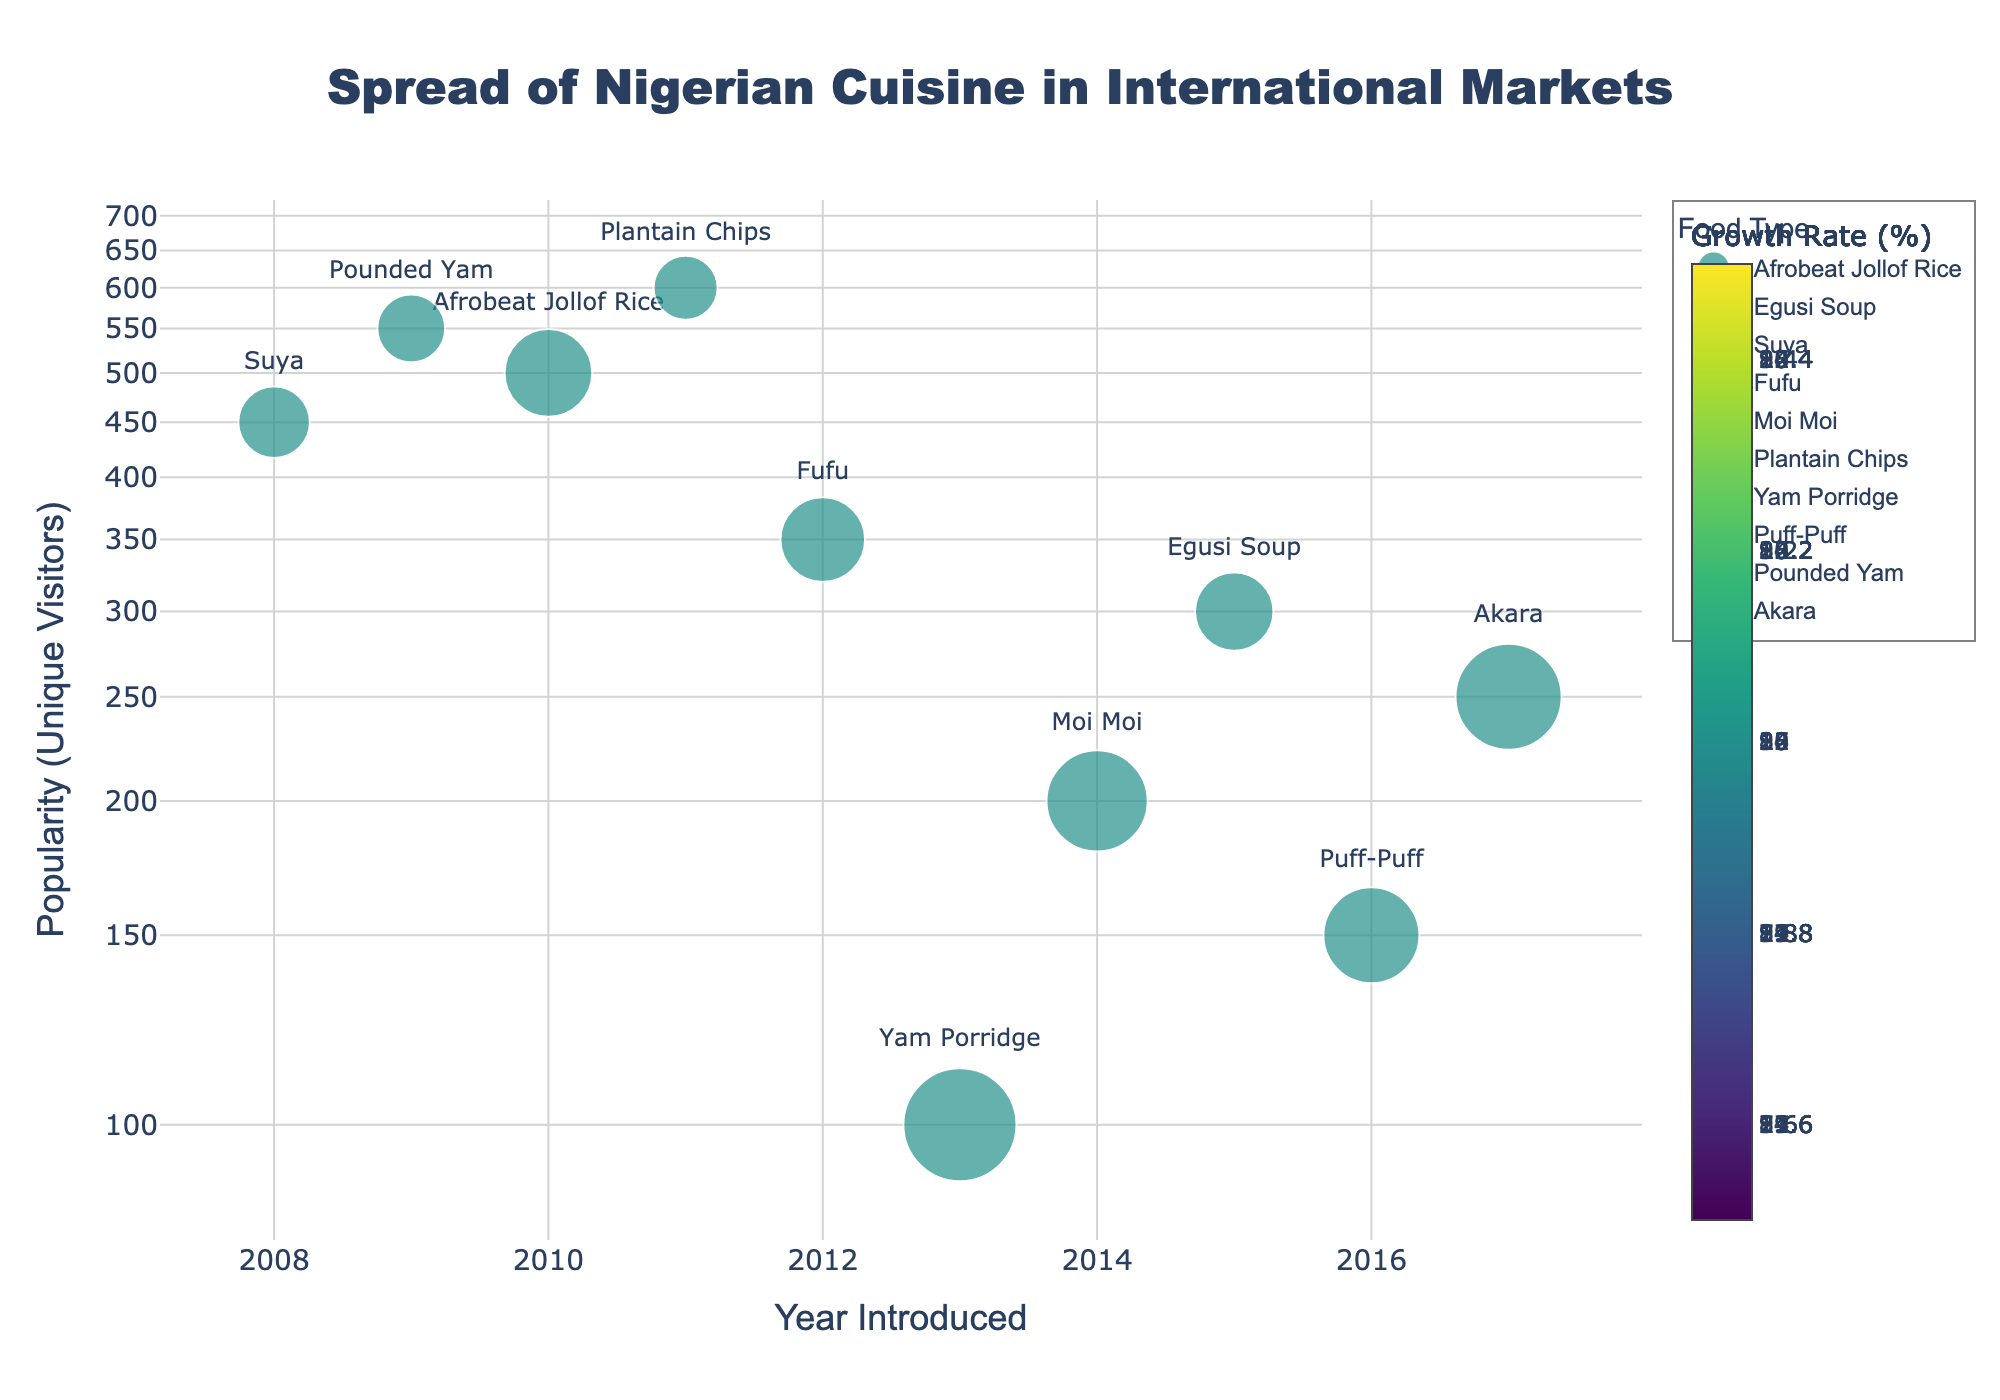When was Suya introduced to the UK? The plot provides the year each type of food was introduced. By locating Suya on the plot, we see it was introduced in 2008.
Answer: 2008 Which food type has the highest growth rate? The color intensity indicates growth rate, and looking at the color bar, the darker the color, the higher the growth rate. Yam Porridge in Japan appears the darkest, indicating the highest growth rate.
Answer: Yam Porridge What's the title of the plot? The plot's title is usually at the top, and here it reads "Spread of Nigerian Cuisine in International Markets."
Answer: Spread of Nigerian Cuisine in International Markets How many food types have a popularity index above 500? Checking the y-axis (log scale for popularity index) and identifying the data points above 500: Afrobeat Jollof Rice and Pounded Yam fall into this category.
Answer: 2 Which country introduced Fufu and in what year? By finding Fufu on the plot and checking the corresponding x-axis value, we see that Australia introduced Fufu in 2012.
Answer: Australia, 2012 What's the growth rate of Akara? Akara's position on the plot shows its growth rate through color (with the color bar as reference), which is 22%.
Answer: 22% Which food type introduced between 2010 and 2014 has the highest popularity index? Examine the food types within the year range 2010-2014 and check for the highest y-axis value (popularity index); Plantain Chips, introduced in 2011, has the highest popularity index of 600.
Answer: Plantain Chips Between Egusi Soup and Moi Moi, which has a higher annual growth rate? Using the color intensity associated with growth rate, Moi Moi's darker color compared to Egusi Soup indicates a higher growth rate of 20% vs. 12%.
Answer: Moi Moi How does the popularity index of Puff-Puff compare to Yam Porridge? Look at both points on the y-axis. Yam Porridge has a lower popularity index (100) compared to Puff-Puff (150).
Answer: Puff-Puff is higher What is the relationship between the size of the markers and another variable? The size of the markers corresponds to the growth rate, indicated by the data key in the plot. A larger marker means a higher growth rate.
Answer: Marker size reflects growth rate 